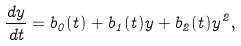Convert formula to latex. <formula><loc_0><loc_0><loc_500><loc_500>\frac { d y } { d t } = b _ { 0 } ( t ) + b _ { 1 } ( t ) y + b _ { 2 } ( t ) y ^ { 2 } ,</formula> 